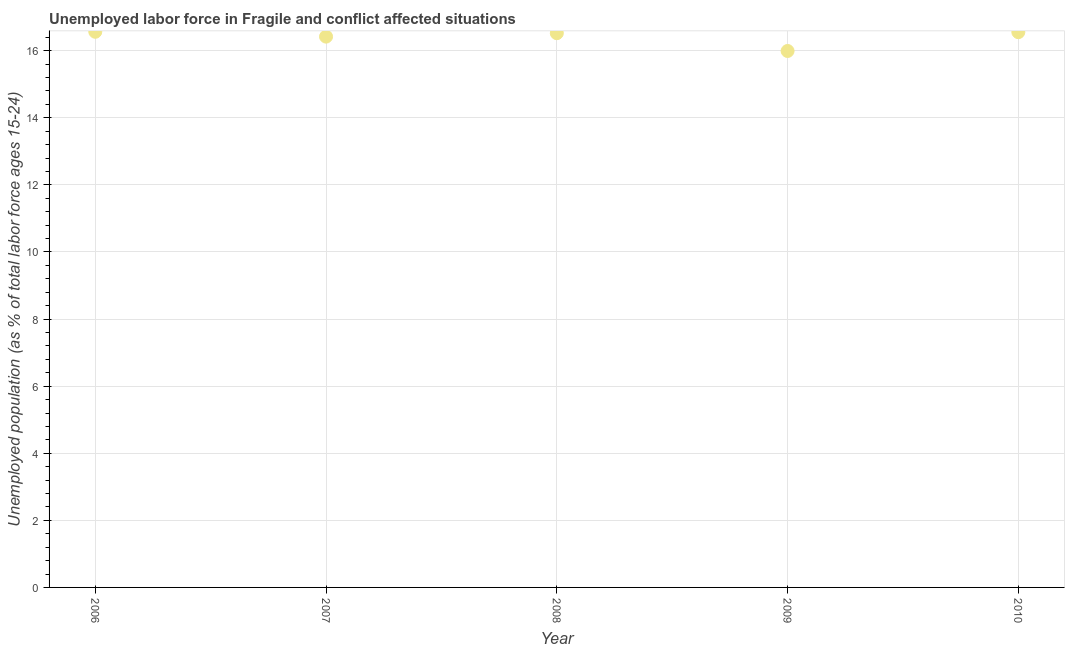What is the total unemployed youth population in 2010?
Provide a short and direct response. 16.55. Across all years, what is the maximum total unemployed youth population?
Your answer should be very brief. 16.57. Across all years, what is the minimum total unemployed youth population?
Give a very brief answer. 15.99. What is the sum of the total unemployed youth population?
Provide a short and direct response. 82.06. What is the difference between the total unemployed youth population in 2006 and 2010?
Provide a short and direct response. 0.01. What is the average total unemployed youth population per year?
Your answer should be very brief. 16.41. What is the median total unemployed youth population?
Provide a succinct answer. 16.52. In how many years, is the total unemployed youth population greater than 5.6 %?
Your answer should be very brief. 5. What is the ratio of the total unemployed youth population in 2008 to that in 2009?
Make the answer very short. 1.03. Is the difference between the total unemployed youth population in 2006 and 2007 greater than the difference between any two years?
Offer a very short reply. No. What is the difference between the highest and the second highest total unemployed youth population?
Your answer should be compact. 0.01. What is the difference between the highest and the lowest total unemployed youth population?
Your answer should be compact. 0.57. Does the graph contain any zero values?
Provide a short and direct response. No. What is the title of the graph?
Your response must be concise. Unemployed labor force in Fragile and conflict affected situations. What is the label or title of the X-axis?
Your answer should be compact. Year. What is the label or title of the Y-axis?
Give a very brief answer. Unemployed population (as % of total labor force ages 15-24). What is the Unemployed population (as % of total labor force ages 15-24) in 2006?
Offer a very short reply. 16.57. What is the Unemployed population (as % of total labor force ages 15-24) in 2007?
Ensure brevity in your answer.  16.42. What is the Unemployed population (as % of total labor force ages 15-24) in 2008?
Keep it short and to the point. 16.52. What is the Unemployed population (as % of total labor force ages 15-24) in 2009?
Provide a succinct answer. 15.99. What is the Unemployed population (as % of total labor force ages 15-24) in 2010?
Offer a very short reply. 16.55. What is the difference between the Unemployed population (as % of total labor force ages 15-24) in 2006 and 2007?
Ensure brevity in your answer.  0.14. What is the difference between the Unemployed population (as % of total labor force ages 15-24) in 2006 and 2008?
Ensure brevity in your answer.  0.04. What is the difference between the Unemployed population (as % of total labor force ages 15-24) in 2006 and 2009?
Provide a succinct answer. 0.57. What is the difference between the Unemployed population (as % of total labor force ages 15-24) in 2006 and 2010?
Ensure brevity in your answer.  0.01. What is the difference between the Unemployed population (as % of total labor force ages 15-24) in 2007 and 2008?
Give a very brief answer. -0.1. What is the difference between the Unemployed population (as % of total labor force ages 15-24) in 2007 and 2009?
Give a very brief answer. 0.43. What is the difference between the Unemployed population (as % of total labor force ages 15-24) in 2007 and 2010?
Make the answer very short. -0.13. What is the difference between the Unemployed population (as % of total labor force ages 15-24) in 2008 and 2009?
Your answer should be very brief. 0.53. What is the difference between the Unemployed population (as % of total labor force ages 15-24) in 2008 and 2010?
Your response must be concise. -0.03. What is the difference between the Unemployed population (as % of total labor force ages 15-24) in 2009 and 2010?
Offer a terse response. -0.56. What is the ratio of the Unemployed population (as % of total labor force ages 15-24) in 2006 to that in 2009?
Provide a short and direct response. 1.04. What is the ratio of the Unemployed population (as % of total labor force ages 15-24) in 2006 to that in 2010?
Your answer should be very brief. 1. What is the ratio of the Unemployed population (as % of total labor force ages 15-24) in 2007 to that in 2009?
Your answer should be compact. 1.03. What is the ratio of the Unemployed population (as % of total labor force ages 15-24) in 2007 to that in 2010?
Keep it short and to the point. 0.99. What is the ratio of the Unemployed population (as % of total labor force ages 15-24) in 2008 to that in 2009?
Provide a succinct answer. 1.03. What is the ratio of the Unemployed population (as % of total labor force ages 15-24) in 2009 to that in 2010?
Your answer should be very brief. 0.97. 